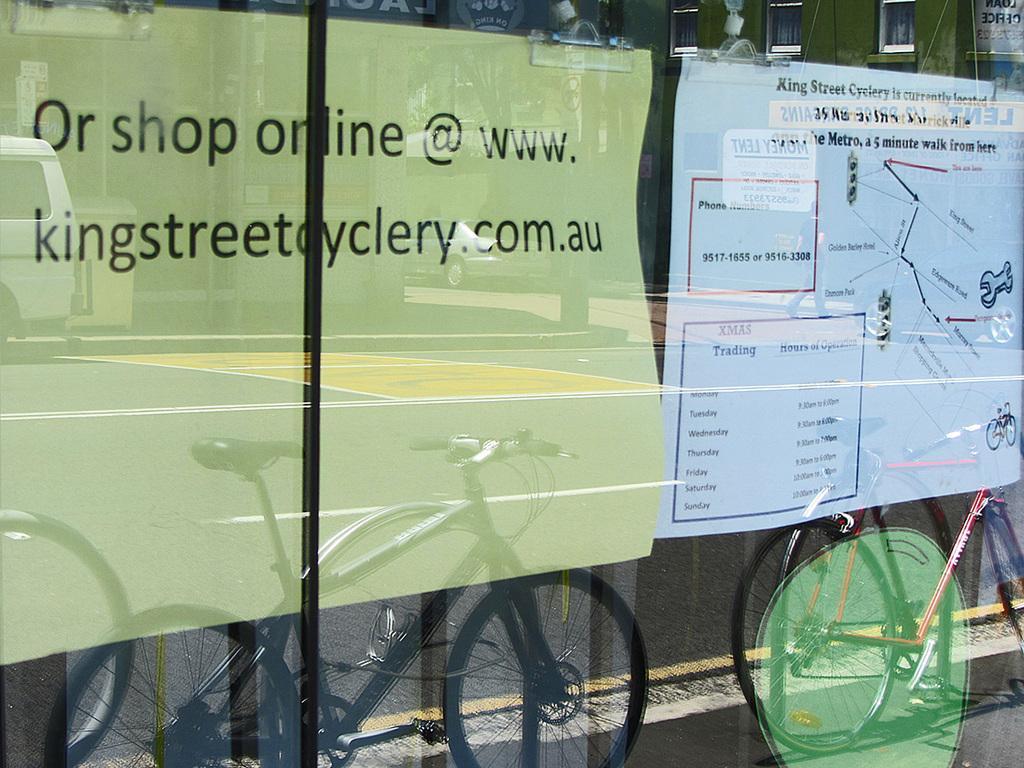Please provide a concise description of this image. In this image we can see glass wall. Through the glass we can see posters. On the glass there are reflections of cycles, road, vehicles and few other objects. 